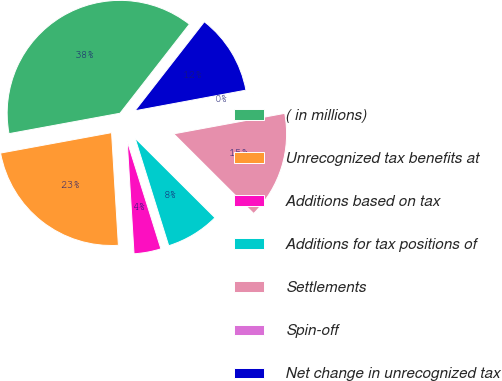Convert chart to OTSL. <chart><loc_0><loc_0><loc_500><loc_500><pie_chart><fcel>( in millions)<fcel>Unrecognized tax benefits at<fcel>Additions based on tax<fcel>Additions for tax positions of<fcel>Settlements<fcel>Spin-off<fcel>Net change in unrecognized tax<nl><fcel>38.43%<fcel>23.07%<fcel>3.86%<fcel>7.7%<fcel>15.38%<fcel>0.02%<fcel>11.54%<nl></chart> 